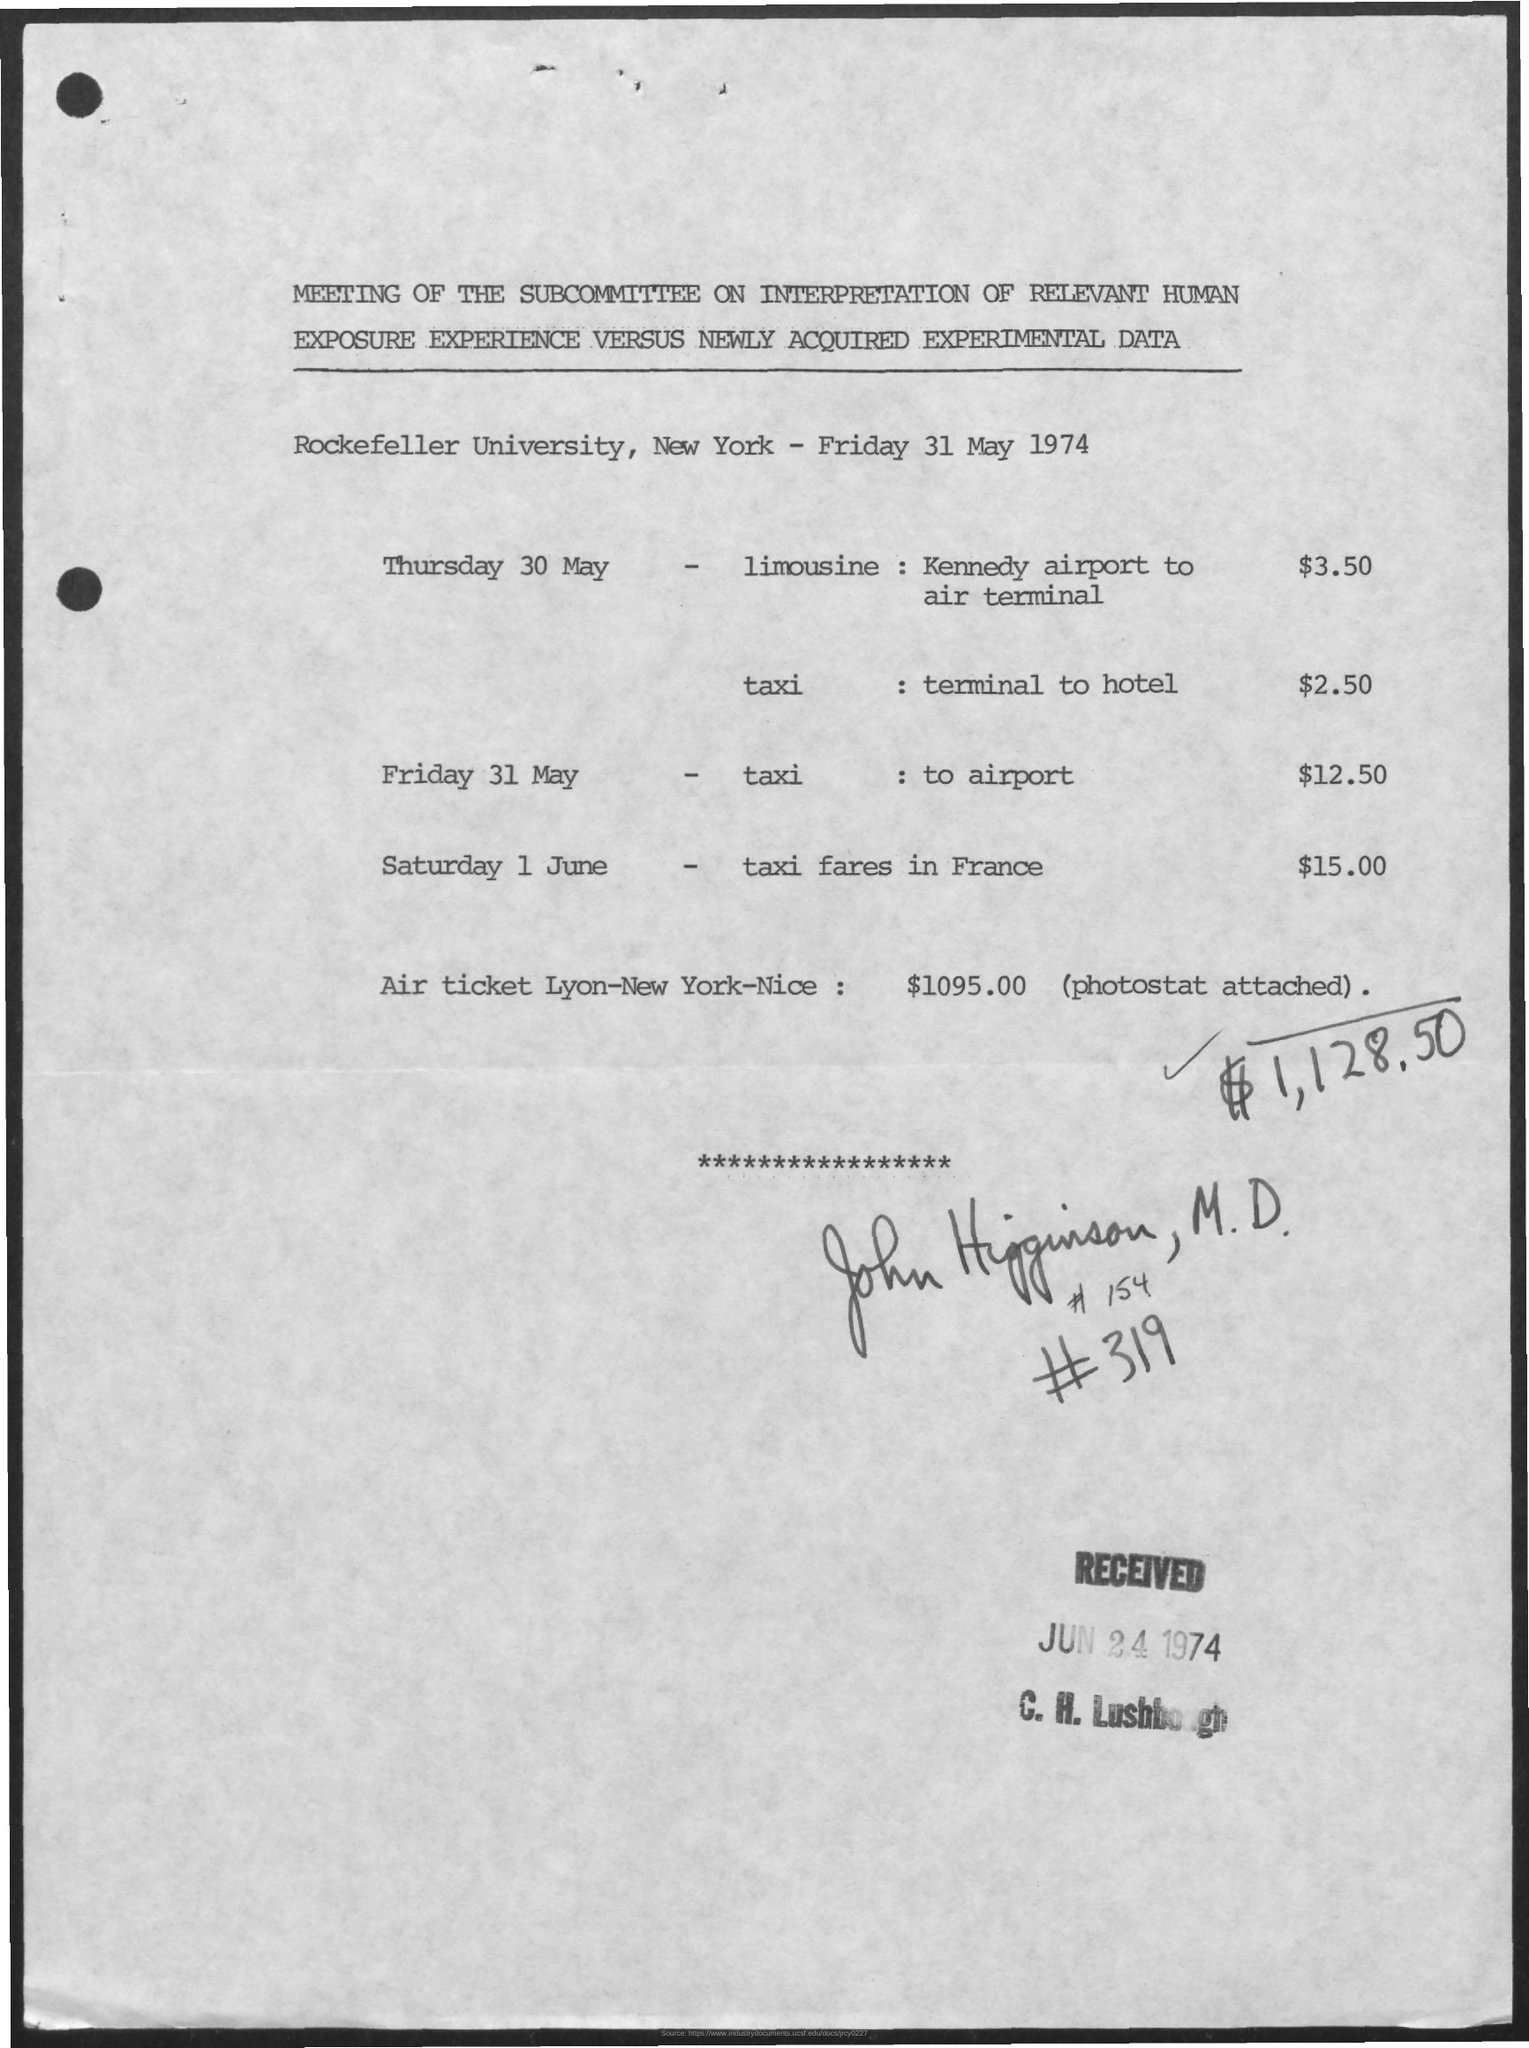What is the taxi fares in France on Saturday 1 June? The document mentions that the taxi fare in France on Saturday 1 June was $15.00 in 1974. Please note that current taxi fares would likely be different due to inflation and other economic changes since then. 